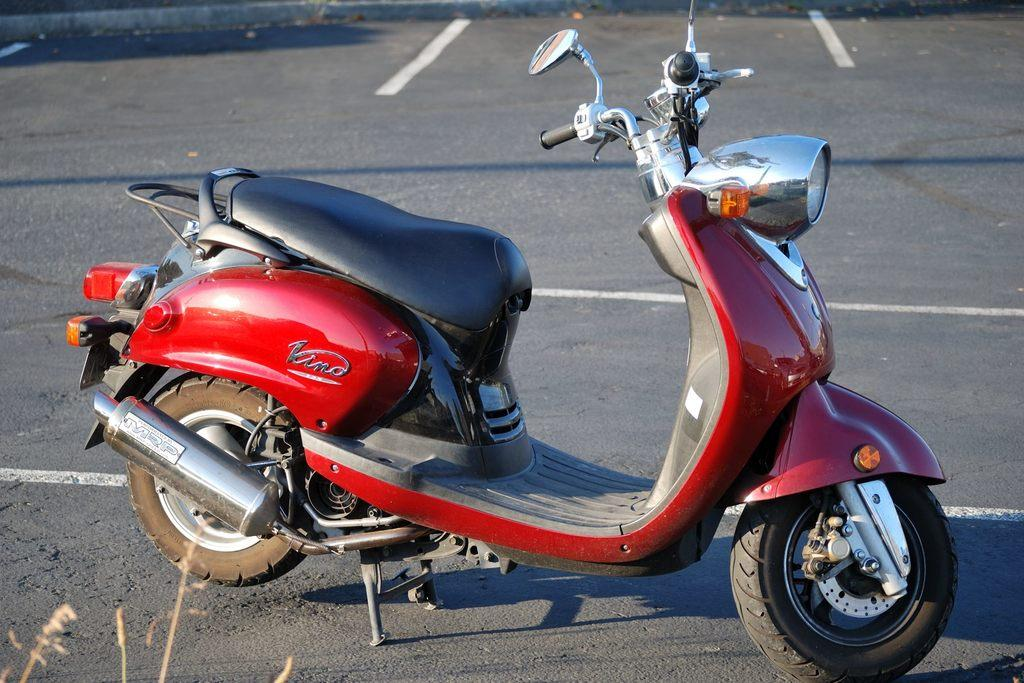What is the main subject of the image? There is a vehicle in the image. Where is the vehicle located? The vehicle is on the road. What can be seen on the road in the image? There are white lines on the road. How many snails can be seen crawling on the vehicle in the image? There are no snails visible on the vehicle in the image. What level of the building is the vehicle parked on in the image? The image does not show a building or a parked vehicle, so it is not possible to determine the level. 